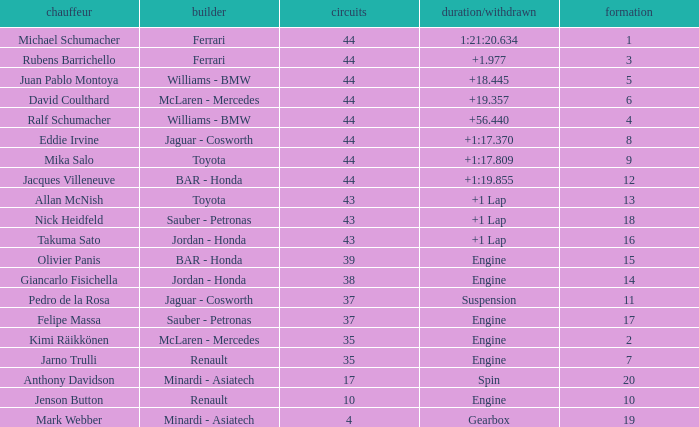What was the retired time on someone who had 43 laps on a grip of 18? +1 Lap. Can you give me this table as a dict? {'header': ['chauffeur', 'builder', 'circuits', 'duration/withdrawn', 'formation'], 'rows': [['Michael Schumacher', 'Ferrari', '44', '1:21:20.634', '1'], ['Rubens Barrichello', 'Ferrari', '44', '+1.977', '3'], ['Juan Pablo Montoya', 'Williams - BMW', '44', '+18.445', '5'], ['David Coulthard', 'McLaren - Mercedes', '44', '+19.357', '6'], ['Ralf Schumacher', 'Williams - BMW', '44', '+56.440', '4'], ['Eddie Irvine', 'Jaguar - Cosworth', '44', '+1:17.370', '8'], ['Mika Salo', 'Toyota', '44', '+1:17.809', '9'], ['Jacques Villeneuve', 'BAR - Honda', '44', '+1:19.855', '12'], ['Allan McNish', 'Toyota', '43', '+1 Lap', '13'], ['Nick Heidfeld', 'Sauber - Petronas', '43', '+1 Lap', '18'], ['Takuma Sato', 'Jordan - Honda', '43', '+1 Lap', '16'], ['Olivier Panis', 'BAR - Honda', '39', 'Engine', '15'], ['Giancarlo Fisichella', 'Jordan - Honda', '38', 'Engine', '14'], ['Pedro de la Rosa', 'Jaguar - Cosworth', '37', 'Suspension', '11'], ['Felipe Massa', 'Sauber - Petronas', '37', 'Engine', '17'], ['Kimi Räikkönen', 'McLaren - Mercedes', '35', 'Engine', '2'], ['Jarno Trulli', 'Renault', '35', 'Engine', '7'], ['Anthony Davidson', 'Minardi - Asiatech', '17', 'Spin', '20'], ['Jenson Button', 'Renault', '10', 'Engine', '10'], ['Mark Webber', 'Minardi - Asiatech', '4', 'Gearbox', '19']]} 